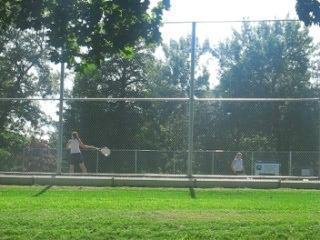How many people are in the picture?
Give a very brief answer. 2. 